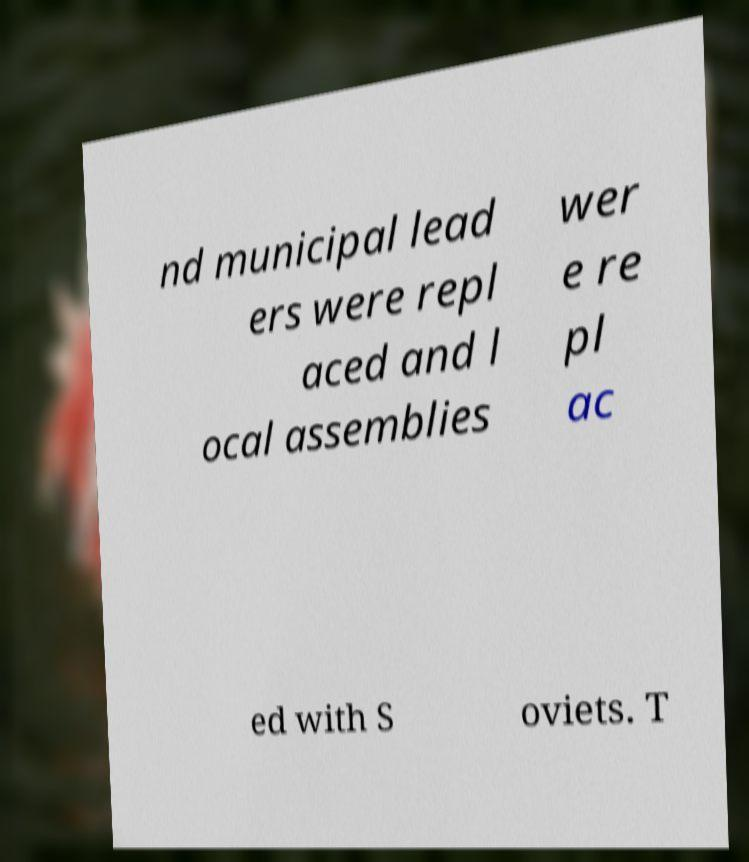Can you read and provide the text displayed in the image?This photo seems to have some interesting text. Can you extract and type it out for me? nd municipal lead ers were repl aced and l ocal assemblies wer e re pl ac ed with S oviets. T 